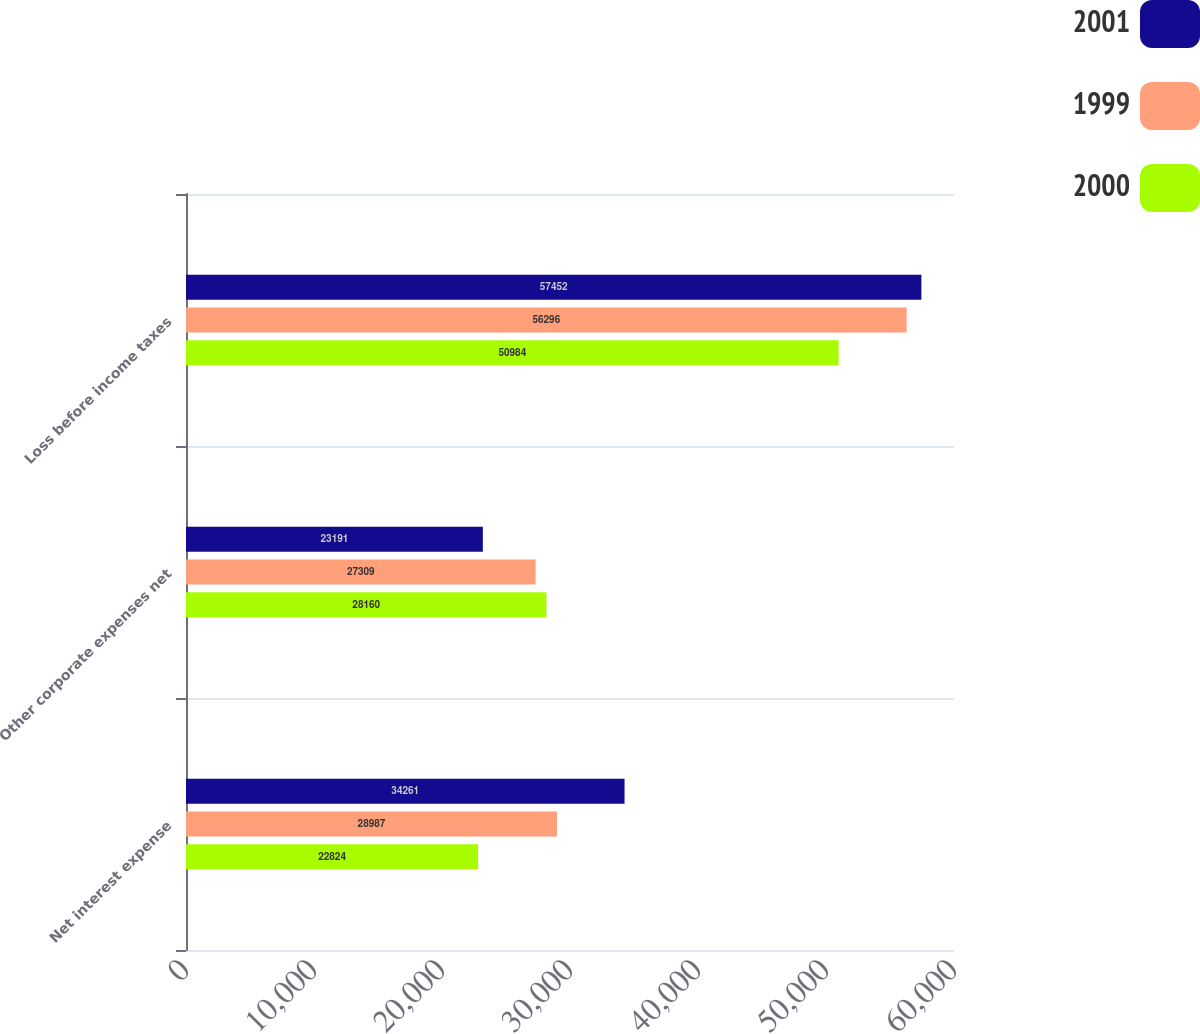Convert chart. <chart><loc_0><loc_0><loc_500><loc_500><stacked_bar_chart><ecel><fcel>Net interest expense<fcel>Other corporate expenses net<fcel>Loss before income taxes<nl><fcel>2001<fcel>34261<fcel>23191<fcel>57452<nl><fcel>1999<fcel>28987<fcel>27309<fcel>56296<nl><fcel>2000<fcel>22824<fcel>28160<fcel>50984<nl></chart> 